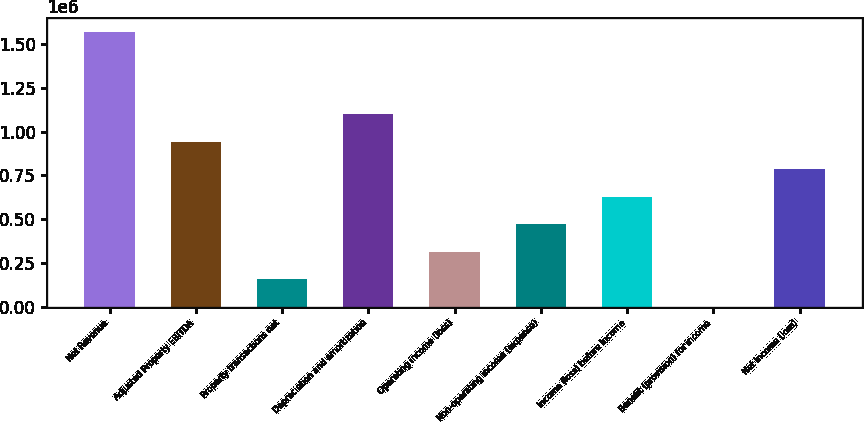Convert chart to OTSL. <chart><loc_0><loc_0><loc_500><loc_500><bar_chart><fcel>Net Revenue<fcel>Adjusted Property EBITDA<fcel>Property transactions net<fcel>Depreciation and amortization<fcel>Operating income (loss)<fcel>Non-operating income (expense)<fcel>Income (loss) before income<fcel>Benefit (provision) for income<fcel>Net income (loss)<nl><fcel>1.57123e+06<fcel>942750<fcel>157156<fcel>1.09987e+06<fcel>314275<fcel>471394<fcel>628513<fcel>37<fcel>785632<nl></chart> 